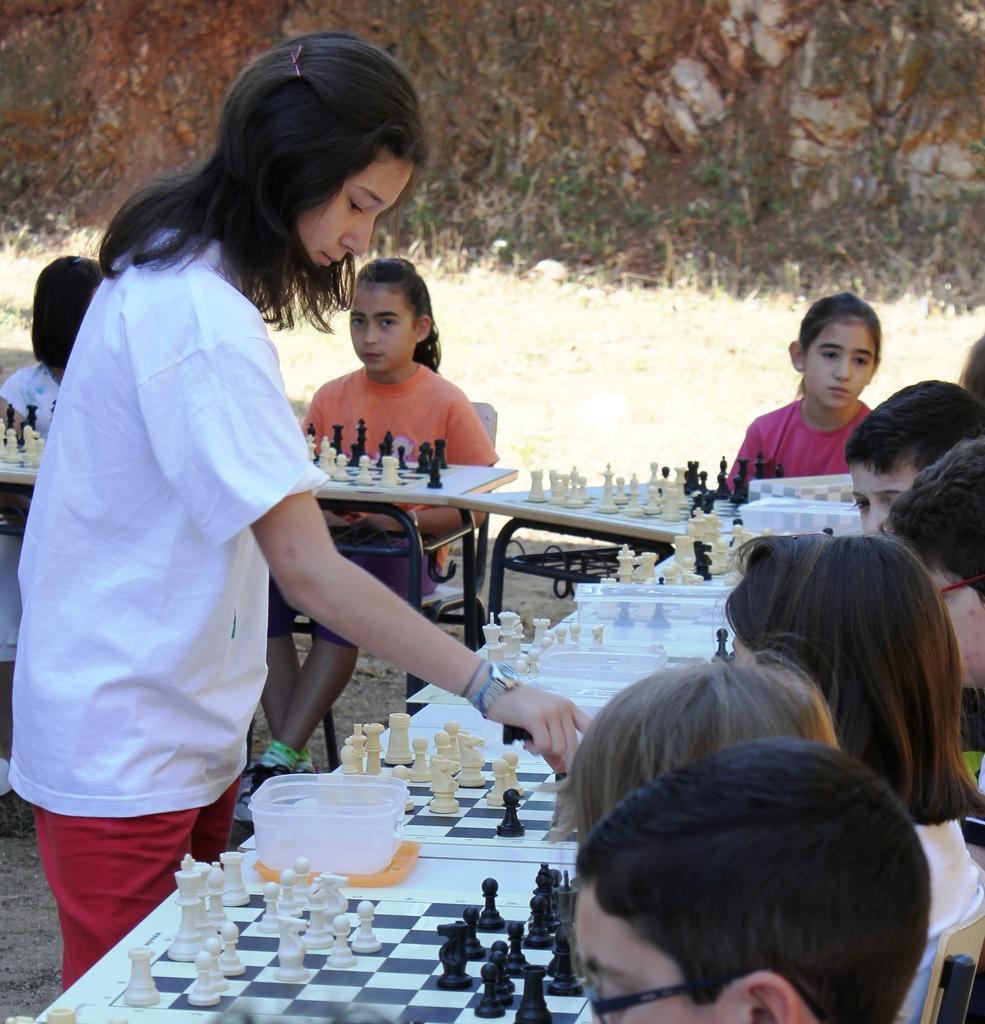Describe this image in one or two sentences. In this picture we can see a woman standing and in front of her there are children sitting playing chess each and everybody is sitting on chairs and tables in front of them having chess boards on it 